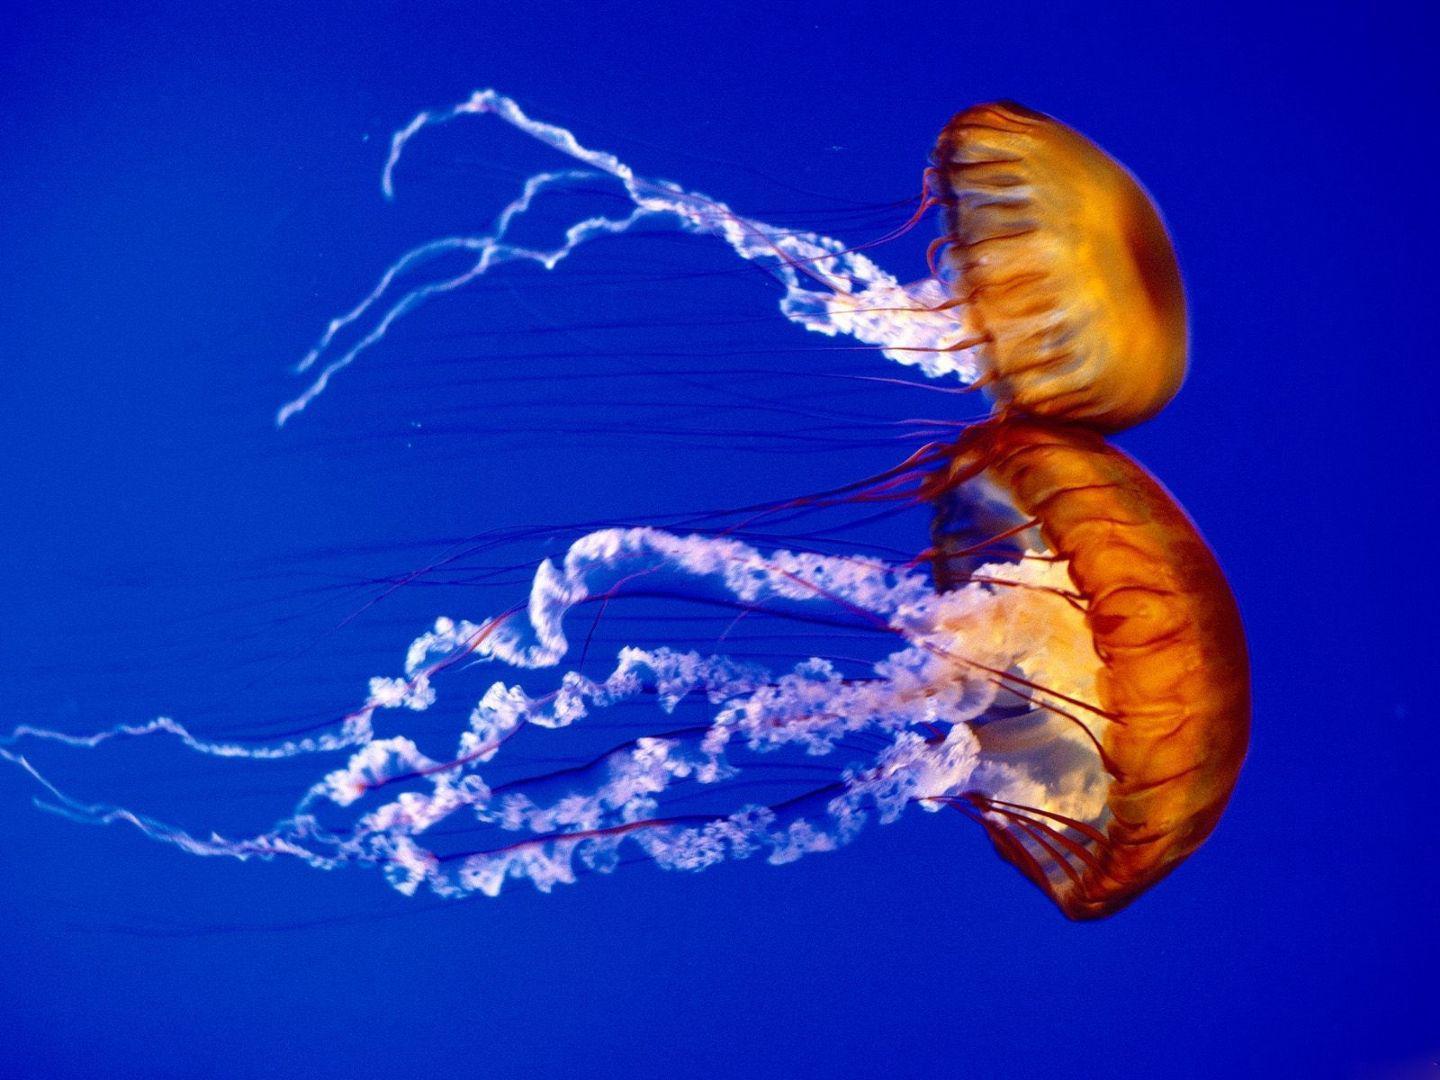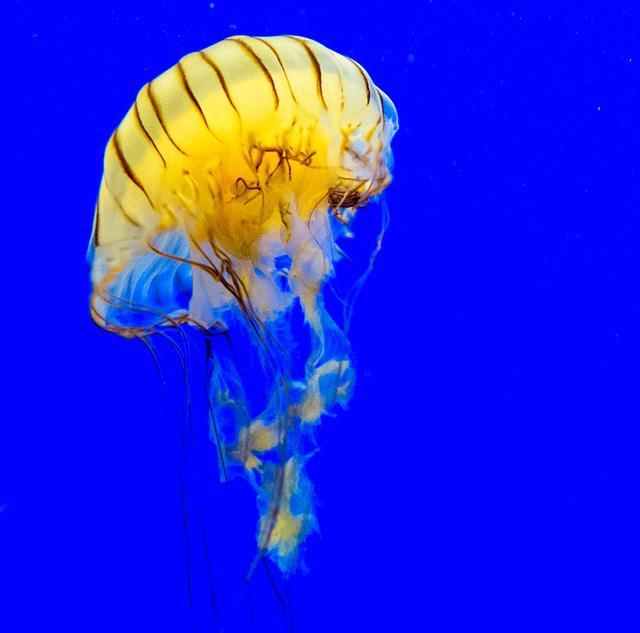The first image is the image on the left, the second image is the image on the right. Examine the images to the left and right. Is the description "The jellyfish in the left and right images are generally the same color, and no single image contains more than two jellyfish." accurate? Answer yes or no. Yes. The first image is the image on the left, the second image is the image on the right. Analyze the images presented: Is the assertion "The jellyfish in the right image are translucent." valid? Answer yes or no. No. 